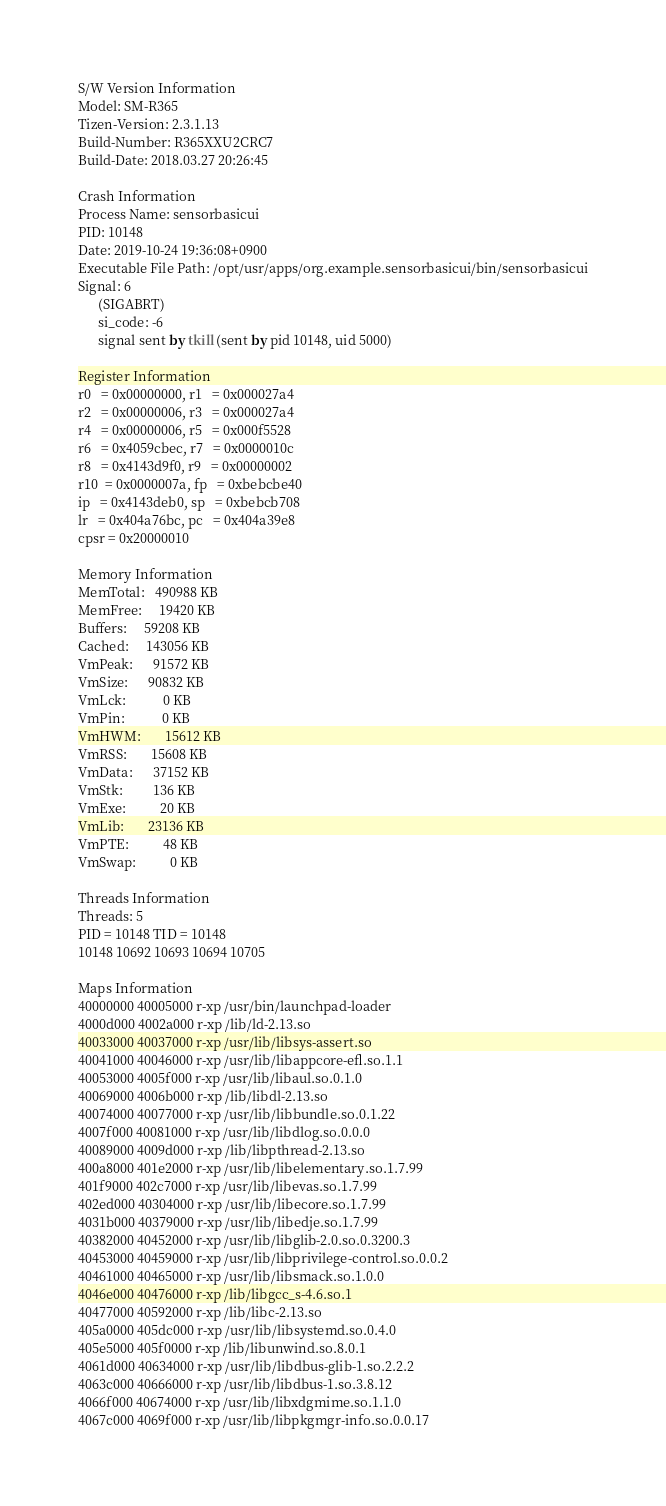Convert code to text. <code><loc_0><loc_0><loc_500><loc_500><_C#_>S/W Version Information
Model: SM-R365
Tizen-Version: 2.3.1.13
Build-Number: R365XXU2CRC7
Build-Date: 2018.03.27 20:26:45

Crash Information
Process Name: sensorbasicui
PID: 10148
Date: 2019-10-24 19:36:08+0900
Executable File Path: /opt/usr/apps/org.example.sensorbasicui/bin/sensorbasicui
Signal: 6
      (SIGABRT)
      si_code: -6
      signal sent by tkill (sent by pid 10148, uid 5000)

Register Information
r0   = 0x00000000, r1   = 0x000027a4
r2   = 0x00000006, r3   = 0x000027a4
r4   = 0x00000006, r5   = 0x000f5528
r6   = 0x4059cbec, r7   = 0x0000010c
r8   = 0x4143d9f0, r9   = 0x00000002
r10  = 0x0000007a, fp   = 0xbebcbe40
ip   = 0x4143deb0, sp   = 0xbebcb708
lr   = 0x404a76bc, pc   = 0x404a39e8
cpsr = 0x20000010

Memory Information
MemTotal:   490988 KB
MemFree:     19420 KB
Buffers:     59208 KB
Cached:     143056 KB
VmPeak:      91572 KB
VmSize:      90832 KB
VmLck:           0 KB
VmPin:           0 KB
VmHWM:       15612 KB
VmRSS:       15608 KB
VmData:      37152 KB
VmStk:         136 KB
VmExe:          20 KB
VmLib:       23136 KB
VmPTE:          48 KB
VmSwap:          0 KB

Threads Information
Threads: 5
PID = 10148 TID = 10148
10148 10692 10693 10694 10705 

Maps Information
40000000 40005000 r-xp /usr/bin/launchpad-loader
4000d000 4002a000 r-xp /lib/ld-2.13.so
40033000 40037000 r-xp /usr/lib/libsys-assert.so
40041000 40046000 r-xp /usr/lib/libappcore-efl.so.1.1
40053000 4005f000 r-xp /usr/lib/libaul.so.0.1.0
40069000 4006b000 r-xp /lib/libdl-2.13.so
40074000 40077000 r-xp /usr/lib/libbundle.so.0.1.22
4007f000 40081000 r-xp /usr/lib/libdlog.so.0.0.0
40089000 4009d000 r-xp /lib/libpthread-2.13.so
400a8000 401e2000 r-xp /usr/lib/libelementary.so.1.7.99
401f9000 402c7000 r-xp /usr/lib/libevas.so.1.7.99
402ed000 40304000 r-xp /usr/lib/libecore.so.1.7.99
4031b000 40379000 r-xp /usr/lib/libedje.so.1.7.99
40382000 40452000 r-xp /usr/lib/libglib-2.0.so.0.3200.3
40453000 40459000 r-xp /usr/lib/libprivilege-control.so.0.0.2
40461000 40465000 r-xp /usr/lib/libsmack.so.1.0.0
4046e000 40476000 r-xp /lib/libgcc_s-4.6.so.1
40477000 40592000 r-xp /lib/libc-2.13.so
405a0000 405dc000 r-xp /usr/lib/libsystemd.so.0.4.0
405e5000 405f0000 r-xp /lib/libunwind.so.8.0.1
4061d000 40634000 r-xp /usr/lib/libdbus-glib-1.so.2.2.2
4063c000 40666000 r-xp /usr/lib/libdbus-1.so.3.8.12
4066f000 40674000 r-xp /usr/lib/libxdgmime.so.1.1.0
4067c000 4069f000 r-xp /usr/lib/libpkgmgr-info.so.0.0.17</code> 